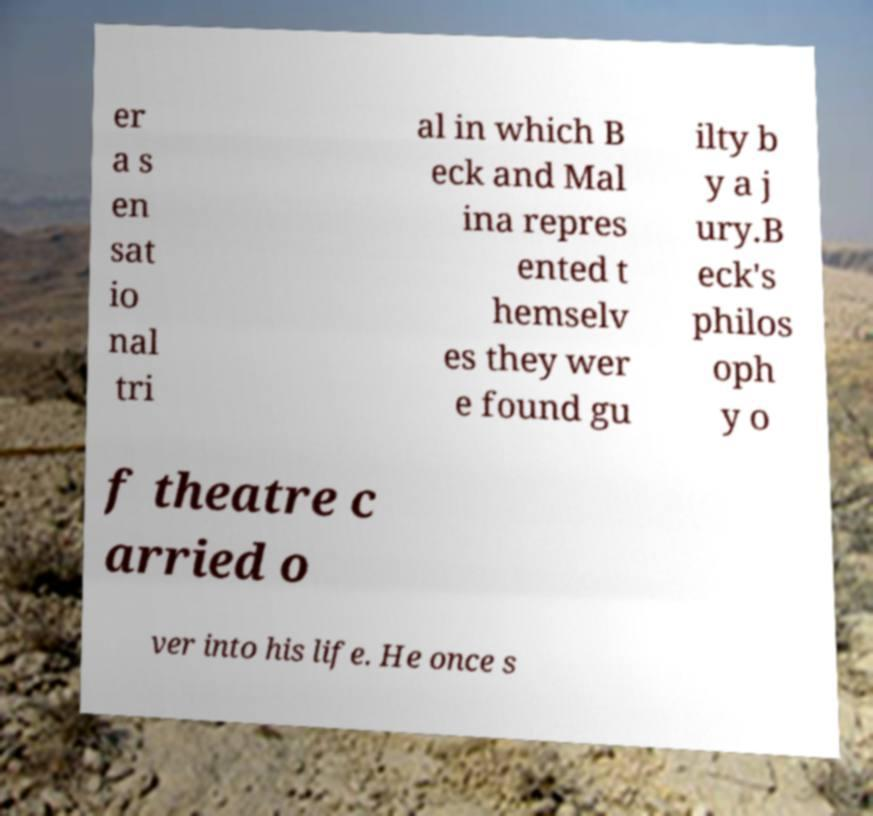Please read and relay the text visible in this image. What does it say? er a s en sat io nal tri al in which B eck and Mal ina repres ented t hemselv es they wer e found gu ilty b y a j ury.B eck's philos oph y o f theatre c arried o ver into his life. He once s 